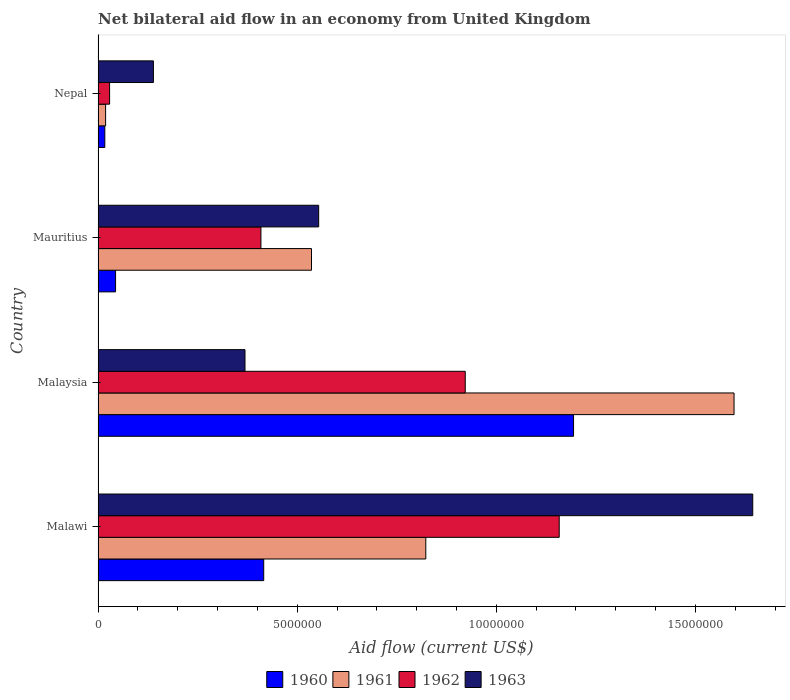How many different coloured bars are there?
Offer a terse response. 4. Are the number of bars per tick equal to the number of legend labels?
Provide a succinct answer. Yes. How many bars are there on the 3rd tick from the bottom?
Ensure brevity in your answer.  4. What is the label of the 4th group of bars from the top?
Keep it short and to the point. Malawi. In how many cases, is the number of bars for a given country not equal to the number of legend labels?
Give a very brief answer. 0. What is the net bilateral aid flow in 1960 in Malawi?
Keep it short and to the point. 4.16e+06. Across all countries, what is the maximum net bilateral aid flow in 1962?
Offer a very short reply. 1.16e+07. In which country was the net bilateral aid flow in 1962 maximum?
Give a very brief answer. Malawi. In which country was the net bilateral aid flow in 1962 minimum?
Your response must be concise. Nepal. What is the total net bilateral aid flow in 1962 in the graph?
Make the answer very short. 2.52e+07. What is the difference between the net bilateral aid flow in 1961 in Mauritius and that in Nepal?
Offer a very short reply. 5.17e+06. What is the difference between the net bilateral aid flow in 1961 in Malaysia and the net bilateral aid flow in 1960 in Nepal?
Your answer should be compact. 1.58e+07. What is the average net bilateral aid flow in 1960 per country?
Your answer should be very brief. 4.18e+06. What is the ratio of the net bilateral aid flow in 1962 in Malawi to that in Mauritius?
Ensure brevity in your answer.  2.83. Is the net bilateral aid flow in 1963 in Malawi less than that in Malaysia?
Offer a terse response. No. What is the difference between the highest and the second highest net bilateral aid flow in 1962?
Offer a terse response. 2.36e+06. What is the difference between the highest and the lowest net bilateral aid flow in 1961?
Provide a short and direct response. 1.58e+07. In how many countries, is the net bilateral aid flow in 1962 greater than the average net bilateral aid flow in 1962 taken over all countries?
Offer a very short reply. 2. Is the sum of the net bilateral aid flow in 1962 in Mauritius and Nepal greater than the maximum net bilateral aid flow in 1963 across all countries?
Your answer should be compact. No. Is it the case that in every country, the sum of the net bilateral aid flow in 1963 and net bilateral aid flow in 1960 is greater than the sum of net bilateral aid flow in 1962 and net bilateral aid flow in 1961?
Give a very brief answer. No. What does the 4th bar from the bottom in Malawi represents?
Keep it short and to the point. 1963. How many bars are there?
Offer a terse response. 16. Are all the bars in the graph horizontal?
Ensure brevity in your answer.  Yes. How many countries are there in the graph?
Provide a succinct answer. 4. Are the values on the major ticks of X-axis written in scientific E-notation?
Ensure brevity in your answer.  No. Does the graph contain any zero values?
Provide a short and direct response. No. How are the legend labels stacked?
Provide a succinct answer. Horizontal. What is the title of the graph?
Provide a succinct answer. Net bilateral aid flow in an economy from United Kingdom. Does "2012" appear as one of the legend labels in the graph?
Offer a very short reply. No. What is the label or title of the Y-axis?
Make the answer very short. Country. What is the Aid flow (current US$) of 1960 in Malawi?
Your response must be concise. 4.16e+06. What is the Aid flow (current US$) of 1961 in Malawi?
Your answer should be very brief. 8.23e+06. What is the Aid flow (current US$) in 1962 in Malawi?
Offer a very short reply. 1.16e+07. What is the Aid flow (current US$) in 1963 in Malawi?
Your answer should be very brief. 1.64e+07. What is the Aid flow (current US$) of 1960 in Malaysia?
Give a very brief answer. 1.19e+07. What is the Aid flow (current US$) of 1961 in Malaysia?
Offer a terse response. 1.60e+07. What is the Aid flow (current US$) in 1962 in Malaysia?
Your response must be concise. 9.22e+06. What is the Aid flow (current US$) in 1963 in Malaysia?
Your response must be concise. 3.69e+06. What is the Aid flow (current US$) of 1961 in Mauritius?
Your answer should be very brief. 5.36e+06. What is the Aid flow (current US$) of 1962 in Mauritius?
Offer a terse response. 4.09e+06. What is the Aid flow (current US$) of 1963 in Mauritius?
Offer a very short reply. 5.54e+06. What is the Aid flow (current US$) of 1962 in Nepal?
Your response must be concise. 2.90e+05. What is the Aid flow (current US$) in 1963 in Nepal?
Offer a very short reply. 1.39e+06. Across all countries, what is the maximum Aid flow (current US$) in 1960?
Offer a terse response. 1.19e+07. Across all countries, what is the maximum Aid flow (current US$) of 1961?
Ensure brevity in your answer.  1.60e+07. Across all countries, what is the maximum Aid flow (current US$) of 1962?
Ensure brevity in your answer.  1.16e+07. Across all countries, what is the maximum Aid flow (current US$) in 1963?
Keep it short and to the point. 1.64e+07. Across all countries, what is the minimum Aid flow (current US$) in 1961?
Offer a very short reply. 1.90e+05. Across all countries, what is the minimum Aid flow (current US$) of 1962?
Your response must be concise. 2.90e+05. Across all countries, what is the minimum Aid flow (current US$) of 1963?
Your answer should be compact. 1.39e+06. What is the total Aid flow (current US$) of 1960 in the graph?
Ensure brevity in your answer.  1.67e+07. What is the total Aid flow (current US$) in 1961 in the graph?
Keep it short and to the point. 2.98e+07. What is the total Aid flow (current US$) of 1962 in the graph?
Your answer should be compact. 2.52e+07. What is the total Aid flow (current US$) in 1963 in the graph?
Keep it short and to the point. 2.71e+07. What is the difference between the Aid flow (current US$) in 1960 in Malawi and that in Malaysia?
Give a very brief answer. -7.78e+06. What is the difference between the Aid flow (current US$) of 1961 in Malawi and that in Malaysia?
Ensure brevity in your answer.  -7.74e+06. What is the difference between the Aid flow (current US$) in 1962 in Malawi and that in Malaysia?
Give a very brief answer. 2.36e+06. What is the difference between the Aid flow (current US$) in 1963 in Malawi and that in Malaysia?
Offer a terse response. 1.28e+07. What is the difference between the Aid flow (current US$) in 1960 in Malawi and that in Mauritius?
Ensure brevity in your answer.  3.72e+06. What is the difference between the Aid flow (current US$) of 1961 in Malawi and that in Mauritius?
Offer a terse response. 2.87e+06. What is the difference between the Aid flow (current US$) of 1962 in Malawi and that in Mauritius?
Your response must be concise. 7.49e+06. What is the difference between the Aid flow (current US$) of 1963 in Malawi and that in Mauritius?
Your answer should be very brief. 1.09e+07. What is the difference between the Aid flow (current US$) in 1960 in Malawi and that in Nepal?
Offer a very short reply. 3.99e+06. What is the difference between the Aid flow (current US$) of 1961 in Malawi and that in Nepal?
Offer a very short reply. 8.04e+06. What is the difference between the Aid flow (current US$) in 1962 in Malawi and that in Nepal?
Offer a very short reply. 1.13e+07. What is the difference between the Aid flow (current US$) in 1963 in Malawi and that in Nepal?
Provide a short and direct response. 1.50e+07. What is the difference between the Aid flow (current US$) in 1960 in Malaysia and that in Mauritius?
Provide a succinct answer. 1.15e+07. What is the difference between the Aid flow (current US$) of 1961 in Malaysia and that in Mauritius?
Provide a succinct answer. 1.06e+07. What is the difference between the Aid flow (current US$) in 1962 in Malaysia and that in Mauritius?
Make the answer very short. 5.13e+06. What is the difference between the Aid flow (current US$) in 1963 in Malaysia and that in Mauritius?
Your answer should be compact. -1.85e+06. What is the difference between the Aid flow (current US$) in 1960 in Malaysia and that in Nepal?
Your response must be concise. 1.18e+07. What is the difference between the Aid flow (current US$) in 1961 in Malaysia and that in Nepal?
Keep it short and to the point. 1.58e+07. What is the difference between the Aid flow (current US$) of 1962 in Malaysia and that in Nepal?
Your answer should be compact. 8.93e+06. What is the difference between the Aid flow (current US$) of 1963 in Malaysia and that in Nepal?
Offer a terse response. 2.30e+06. What is the difference between the Aid flow (current US$) in 1960 in Mauritius and that in Nepal?
Your answer should be very brief. 2.70e+05. What is the difference between the Aid flow (current US$) of 1961 in Mauritius and that in Nepal?
Provide a succinct answer. 5.17e+06. What is the difference between the Aid flow (current US$) of 1962 in Mauritius and that in Nepal?
Provide a succinct answer. 3.80e+06. What is the difference between the Aid flow (current US$) of 1963 in Mauritius and that in Nepal?
Provide a succinct answer. 4.15e+06. What is the difference between the Aid flow (current US$) of 1960 in Malawi and the Aid flow (current US$) of 1961 in Malaysia?
Offer a terse response. -1.18e+07. What is the difference between the Aid flow (current US$) of 1960 in Malawi and the Aid flow (current US$) of 1962 in Malaysia?
Provide a succinct answer. -5.06e+06. What is the difference between the Aid flow (current US$) in 1960 in Malawi and the Aid flow (current US$) in 1963 in Malaysia?
Your answer should be very brief. 4.70e+05. What is the difference between the Aid flow (current US$) of 1961 in Malawi and the Aid flow (current US$) of 1962 in Malaysia?
Make the answer very short. -9.90e+05. What is the difference between the Aid flow (current US$) in 1961 in Malawi and the Aid flow (current US$) in 1963 in Malaysia?
Keep it short and to the point. 4.54e+06. What is the difference between the Aid flow (current US$) of 1962 in Malawi and the Aid flow (current US$) of 1963 in Malaysia?
Make the answer very short. 7.89e+06. What is the difference between the Aid flow (current US$) in 1960 in Malawi and the Aid flow (current US$) in 1961 in Mauritius?
Keep it short and to the point. -1.20e+06. What is the difference between the Aid flow (current US$) in 1960 in Malawi and the Aid flow (current US$) in 1962 in Mauritius?
Your response must be concise. 7.00e+04. What is the difference between the Aid flow (current US$) in 1960 in Malawi and the Aid flow (current US$) in 1963 in Mauritius?
Offer a very short reply. -1.38e+06. What is the difference between the Aid flow (current US$) in 1961 in Malawi and the Aid flow (current US$) in 1962 in Mauritius?
Keep it short and to the point. 4.14e+06. What is the difference between the Aid flow (current US$) of 1961 in Malawi and the Aid flow (current US$) of 1963 in Mauritius?
Give a very brief answer. 2.69e+06. What is the difference between the Aid flow (current US$) in 1962 in Malawi and the Aid flow (current US$) in 1963 in Mauritius?
Give a very brief answer. 6.04e+06. What is the difference between the Aid flow (current US$) of 1960 in Malawi and the Aid flow (current US$) of 1961 in Nepal?
Your answer should be compact. 3.97e+06. What is the difference between the Aid flow (current US$) in 1960 in Malawi and the Aid flow (current US$) in 1962 in Nepal?
Your answer should be compact. 3.87e+06. What is the difference between the Aid flow (current US$) in 1960 in Malawi and the Aid flow (current US$) in 1963 in Nepal?
Ensure brevity in your answer.  2.77e+06. What is the difference between the Aid flow (current US$) in 1961 in Malawi and the Aid flow (current US$) in 1962 in Nepal?
Offer a terse response. 7.94e+06. What is the difference between the Aid flow (current US$) in 1961 in Malawi and the Aid flow (current US$) in 1963 in Nepal?
Ensure brevity in your answer.  6.84e+06. What is the difference between the Aid flow (current US$) in 1962 in Malawi and the Aid flow (current US$) in 1963 in Nepal?
Make the answer very short. 1.02e+07. What is the difference between the Aid flow (current US$) in 1960 in Malaysia and the Aid flow (current US$) in 1961 in Mauritius?
Your answer should be compact. 6.58e+06. What is the difference between the Aid flow (current US$) in 1960 in Malaysia and the Aid flow (current US$) in 1962 in Mauritius?
Make the answer very short. 7.85e+06. What is the difference between the Aid flow (current US$) in 1960 in Malaysia and the Aid flow (current US$) in 1963 in Mauritius?
Provide a short and direct response. 6.40e+06. What is the difference between the Aid flow (current US$) in 1961 in Malaysia and the Aid flow (current US$) in 1962 in Mauritius?
Provide a succinct answer. 1.19e+07. What is the difference between the Aid flow (current US$) in 1961 in Malaysia and the Aid flow (current US$) in 1963 in Mauritius?
Your answer should be very brief. 1.04e+07. What is the difference between the Aid flow (current US$) of 1962 in Malaysia and the Aid flow (current US$) of 1963 in Mauritius?
Your response must be concise. 3.68e+06. What is the difference between the Aid flow (current US$) in 1960 in Malaysia and the Aid flow (current US$) in 1961 in Nepal?
Offer a very short reply. 1.18e+07. What is the difference between the Aid flow (current US$) in 1960 in Malaysia and the Aid flow (current US$) in 1962 in Nepal?
Provide a short and direct response. 1.16e+07. What is the difference between the Aid flow (current US$) in 1960 in Malaysia and the Aid flow (current US$) in 1963 in Nepal?
Your answer should be very brief. 1.06e+07. What is the difference between the Aid flow (current US$) in 1961 in Malaysia and the Aid flow (current US$) in 1962 in Nepal?
Offer a very short reply. 1.57e+07. What is the difference between the Aid flow (current US$) in 1961 in Malaysia and the Aid flow (current US$) in 1963 in Nepal?
Make the answer very short. 1.46e+07. What is the difference between the Aid flow (current US$) in 1962 in Malaysia and the Aid flow (current US$) in 1963 in Nepal?
Provide a succinct answer. 7.83e+06. What is the difference between the Aid flow (current US$) of 1960 in Mauritius and the Aid flow (current US$) of 1961 in Nepal?
Make the answer very short. 2.50e+05. What is the difference between the Aid flow (current US$) of 1960 in Mauritius and the Aid flow (current US$) of 1962 in Nepal?
Keep it short and to the point. 1.50e+05. What is the difference between the Aid flow (current US$) in 1960 in Mauritius and the Aid flow (current US$) in 1963 in Nepal?
Offer a terse response. -9.50e+05. What is the difference between the Aid flow (current US$) of 1961 in Mauritius and the Aid flow (current US$) of 1962 in Nepal?
Keep it short and to the point. 5.07e+06. What is the difference between the Aid flow (current US$) of 1961 in Mauritius and the Aid flow (current US$) of 1963 in Nepal?
Offer a very short reply. 3.97e+06. What is the difference between the Aid flow (current US$) in 1962 in Mauritius and the Aid flow (current US$) in 1963 in Nepal?
Your answer should be very brief. 2.70e+06. What is the average Aid flow (current US$) in 1960 per country?
Your answer should be very brief. 4.18e+06. What is the average Aid flow (current US$) of 1961 per country?
Give a very brief answer. 7.44e+06. What is the average Aid flow (current US$) in 1962 per country?
Your response must be concise. 6.30e+06. What is the average Aid flow (current US$) of 1963 per country?
Make the answer very short. 6.76e+06. What is the difference between the Aid flow (current US$) of 1960 and Aid flow (current US$) of 1961 in Malawi?
Give a very brief answer. -4.07e+06. What is the difference between the Aid flow (current US$) in 1960 and Aid flow (current US$) in 1962 in Malawi?
Make the answer very short. -7.42e+06. What is the difference between the Aid flow (current US$) in 1960 and Aid flow (current US$) in 1963 in Malawi?
Your answer should be compact. -1.23e+07. What is the difference between the Aid flow (current US$) in 1961 and Aid flow (current US$) in 1962 in Malawi?
Your answer should be compact. -3.35e+06. What is the difference between the Aid flow (current US$) in 1961 and Aid flow (current US$) in 1963 in Malawi?
Ensure brevity in your answer.  -8.21e+06. What is the difference between the Aid flow (current US$) in 1962 and Aid flow (current US$) in 1963 in Malawi?
Your answer should be compact. -4.86e+06. What is the difference between the Aid flow (current US$) in 1960 and Aid flow (current US$) in 1961 in Malaysia?
Offer a terse response. -4.03e+06. What is the difference between the Aid flow (current US$) in 1960 and Aid flow (current US$) in 1962 in Malaysia?
Offer a terse response. 2.72e+06. What is the difference between the Aid flow (current US$) of 1960 and Aid flow (current US$) of 1963 in Malaysia?
Ensure brevity in your answer.  8.25e+06. What is the difference between the Aid flow (current US$) in 1961 and Aid flow (current US$) in 1962 in Malaysia?
Offer a terse response. 6.75e+06. What is the difference between the Aid flow (current US$) in 1961 and Aid flow (current US$) in 1963 in Malaysia?
Your answer should be very brief. 1.23e+07. What is the difference between the Aid flow (current US$) of 1962 and Aid flow (current US$) of 1963 in Malaysia?
Your response must be concise. 5.53e+06. What is the difference between the Aid flow (current US$) in 1960 and Aid flow (current US$) in 1961 in Mauritius?
Keep it short and to the point. -4.92e+06. What is the difference between the Aid flow (current US$) in 1960 and Aid flow (current US$) in 1962 in Mauritius?
Offer a terse response. -3.65e+06. What is the difference between the Aid flow (current US$) in 1960 and Aid flow (current US$) in 1963 in Mauritius?
Offer a very short reply. -5.10e+06. What is the difference between the Aid flow (current US$) of 1961 and Aid flow (current US$) of 1962 in Mauritius?
Ensure brevity in your answer.  1.27e+06. What is the difference between the Aid flow (current US$) in 1962 and Aid flow (current US$) in 1963 in Mauritius?
Your answer should be very brief. -1.45e+06. What is the difference between the Aid flow (current US$) in 1960 and Aid flow (current US$) in 1963 in Nepal?
Give a very brief answer. -1.22e+06. What is the difference between the Aid flow (current US$) in 1961 and Aid flow (current US$) in 1963 in Nepal?
Your answer should be very brief. -1.20e+06. What is the difference between the Aid flow (current US$) of 1962 and Aid flow (current US$) of 1963 in Nepal?
Your answer should be very brief. -1.10e+06. What is the ratio of the Aid flow (current US$) of 1960 in Malawi to that in Malaysia?
Your answer should be very brief. 0.35. What is the ratio of the Aid flow (current US$) in 1961 in Malawi to that in Malaysia?
Your answer should be very brief. 0.52. What is the ratio of the Aid flow (current US$) of 1962 in Malawi to that in Malaysia?
Provide a succinct answer. 1.26. What is the ratio of the Aid flow (current US$) of 1963 in Malawi to that in Malaysia?
Provide a short and direct response. 4.46. What is the ratio of the Aid flow (current US$) of 1960 in Malawi to that in Mauritius?
Offer a very short reply. 9.45. What is the ratio of the Aid flow (current US$) in 1961 in Malawi to that in Mauritius?
Provide a short and direct response. 1.54. What is the ratio of the Aid flow (current US$) in 1962 in Malawi to that in Mauritius?
Give a very brief answer. 2.83. What is the ratio of the Aid flow (current US$) in 1963 in Malawi to that in Mauritius?
Offer a terse response. 2.97. What is the ratio of the Aid flow (current US$) in 1960 in Malawi to that in Nepal?
Give a very brief answer. 24.47. What is the ratio of the Aid flow (current US$) of 1961 in Malawi to that in Nepal?
Provide a short and direct response. 43.32. What is the ratio of the Aid flow (current US$) in 1962 in Malawi to that in Nepal?
Offer a very short reply. 39.93. What is the ratio of the Aid flow (current US$) of 1963 in Malawi to that in Nepal?
Provide a short and direct response. 11.83. What is the ratio of the Aid flow (current US$) in 1960 in Malaysia to that in Mauritius?
Your answer should be very brief. 27.14. What is the ratio of the Aid flow (current US$) in 1961 in Malaysia to that in Mauritius?
Provide a succinct answer. 2.98. What is the ratio of the Aid flow (current US$) in 1962 in Malaysia to that in Mauritius?
Your answer should be compact. 2.25. What is the ratio of the Aid flow (current US$) in 1963 in Malaysia to that in Mauritius?
Your answer should be compact. 0.67. What is the ratio of the Aid flow (current US$) in 1960 in Malaysia to that in Nepal?
Give a very brief answer. 70.24. What is the ratio of the Aid flow (current US$) of 1961 in Malaysia to that in Nepal?
Offer a terse response. 84.05. What is the ratio of the Aid flow (current US$) of 1962 in Malaysia to that in Nepal?
Provide a succinct answer. 31.79. What is the ratio of the Aid flow (current US$) in 1963 in Malaysia to that in Nepal?
Keep it short and to the point. 2.65. What is the ratio of the Aid flow (current US$) of 1960 in Mauritius to that in Nepal?
Provide a short and direct response. 2.59. What is the ratio of the Aid flow (current US$) of 1961 in Mauritius to that in Nepal?
Ensure brevity in your answer.  28.21. What is the ratio of the Aid flow (current US$) in 1962 in Mauritius to that in Nepal?
Provide a succinct answer. 14.1. What is the ratio of the Aid flow (current US$) of 1963 in Mauritius to that in Nepal?
Your response must be concise. 3.99. What is the difference between the highest and the second highest Aid flow (current US$) of 1960?
Keep it short and to the point. 7.78e+06. What is the difference between the highest and the second highest Aid flow (current US$) in 1961?
Provide a short and direct response. 7.74e+06. What is the difference between the highest and the second highest Aid flow (current US$) of 1962?
Your response must be concise. 2.36e+06. What is the difference between the highest and the second highest Aid flow (current US$) of 1963?
Your answer should be very brief. 1.09e+07. What is the difference between the highest and the lowest Aid flow (current US$) in 1960?
Provide a succinct answer. 1.18e+07. What is the difference between the highest and the lowest Aid flow (current US$) of 1961?
Provide a succinct answer. 1.58e+07. What is the difference between the highest and the lowest Aid flow (current US$) of 1962?
Make the answer very short. 1.13e+07. What is the difference between the highest and the lowest Aid flow (current US$) in 1963?
Your response must be concise. 1.50e+07. 